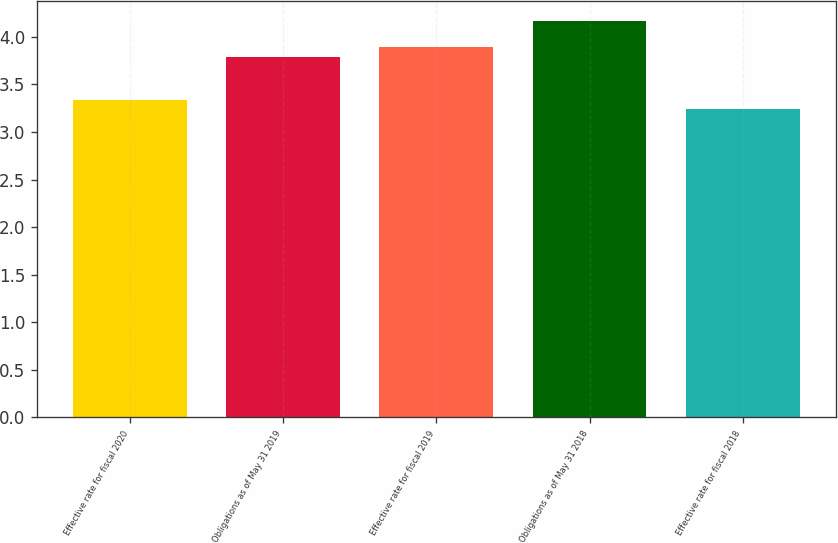<chart> <loc_0><loc_0><loc_500><loc_500><bar_chart><fcel>Effective rate for fiscal 2020<fcel>Obligations as of May 31 2019<fcel>Effective rate for fiscal 2019<fcel>Obligations as of May 31 2018<fcel>Effective rate for fiscal 2018<nl><fcel>3.34<fcel>3.79<fcel>3.89<fcel>4.17<fcel>3.24<nl></chart> 